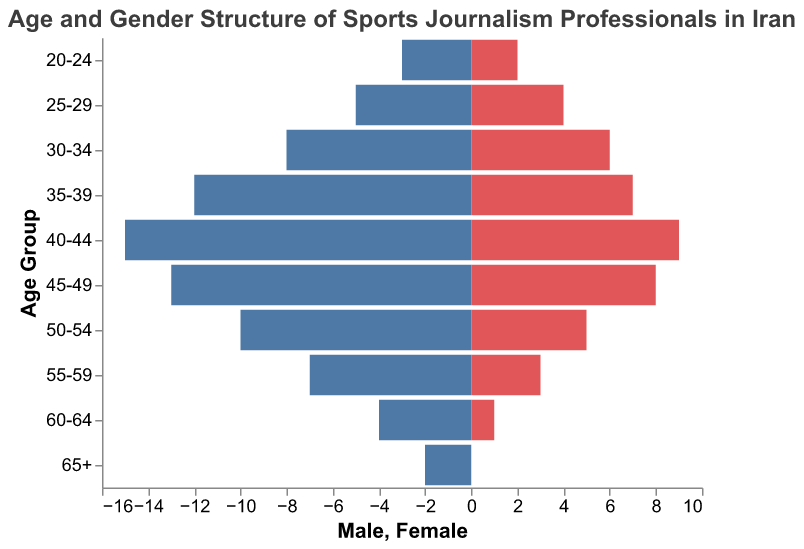Which age group has the highest number of male sports journalism professionals? To find the age group with the highest number of male professionals, look for the bar on the left side that extends the farthest. The longest bar corresponds to the age group 40-44, where the number of males is 15.
Answer: 40-44 Which age group has the highest number of female sports journalism professionals? To identify the age group with the highest number of female professionals, look for the longest bar on the right side. The longest bar corresponds to the age group 40-44, where the number of females is 9.
Answer: 40-44 How do the numbers of male and female journalism professionals compare in the 35-39 age group? Look at the bars representing the age group 35-39. The bar for males extends to 12, whereas the bar for females extends to 7. This shows there are more males than females in this age group.
Answer: More males than females What's the total number of journalism professionals in the 50-54 age group? Add together the male and female values for the 50-54 age group. The number of males is 10 and the number of females is 5, so the total is 15.
Answer: 15 Which age group has a higher ratio of males to females, the 25-29 or the 55-59 age group? For the 25-29 age group, the ratio is 5 males to 4 females (5/4 = 1.25). For the 55-59 age group, the ratio is 7 males to 3 females (7/3 ≈ 2.33). Hence, the 55-59 age group has a higher ratio.
Answer: 55-59 How does the number of females in the 60-64 age group compare to the number of males in the same group? The bar for females in the 60-64 age group extends to 1, while the bar for males extends to 4. Thus, there are more males than females in this age group.
Answer: More males than females What is the difference between male and female journalism professionals in the 45-49 age group? Subtract the number of females from the number of males in the age group 45-49. The number of males is 13 and the number of females is 8, so the difference is 13 - 8 = 5.
Answer: 5 What percentage of the 20-24 age group are females? To find the percentage, divide the number of females by the total number of professionals in the 20-24 age group and multiply by 100. The number of females is 2 and the total is 5 (3 males + 2 females). So, (2/5) * 100 = 40%.
Answer: 40% In which age group do males and females have the smallest numerical difference? Calculate the numerical difference between males and females in each age group. The smallest difference is in the 60-64 age group where the difference is 4 - 1 = 3.
Answer: 60-64 What is the average number of male professionals across all age groups? Sum up the number of males in all age groups and then divide by the number of age groups. The total number of males is 79, and there are 10 age groups, so the average is 79/10 = 7.9.
Answer: 7.9 